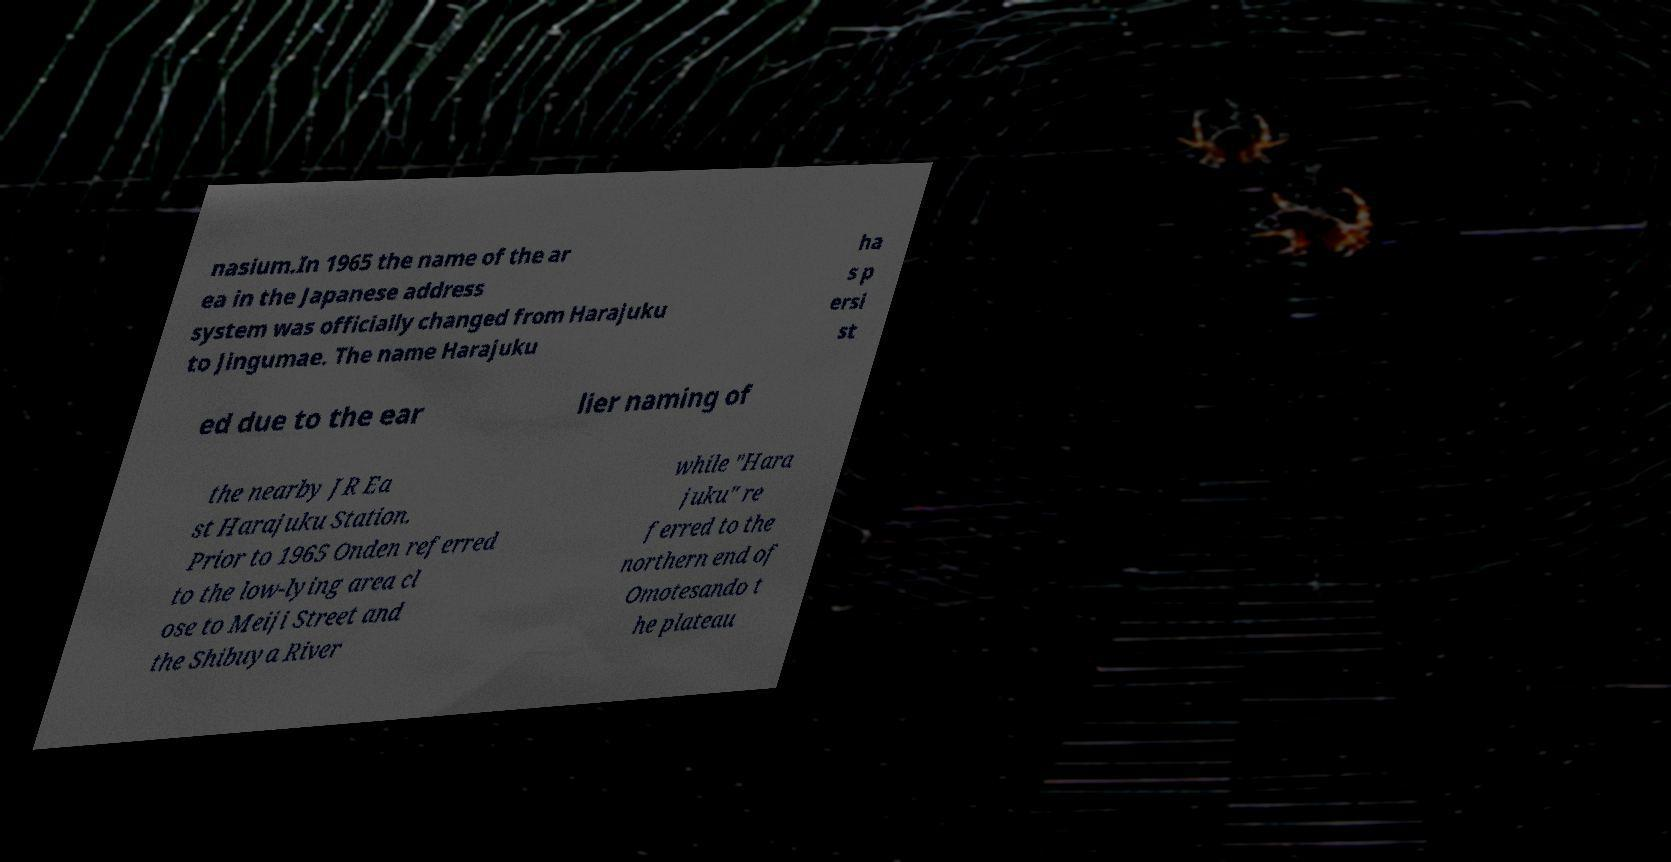There's text embedded in this image that I need extracted. Can you transcribe it verbatim? nasium.In 1965 the name of the ar ea in the Japanese address system was officially changed from Harajuku to Jingumae. The name Harajuku ha s p ersi st ed due to the ear lier naming of the nearby JR Ea st Harajuku Station. Prior to 1965 Onden referred to the low-lying area cl ose to Meiji Street and the Shibuya River while "Hara juku" re ferred to the northern end of Omotesando t he plateau 